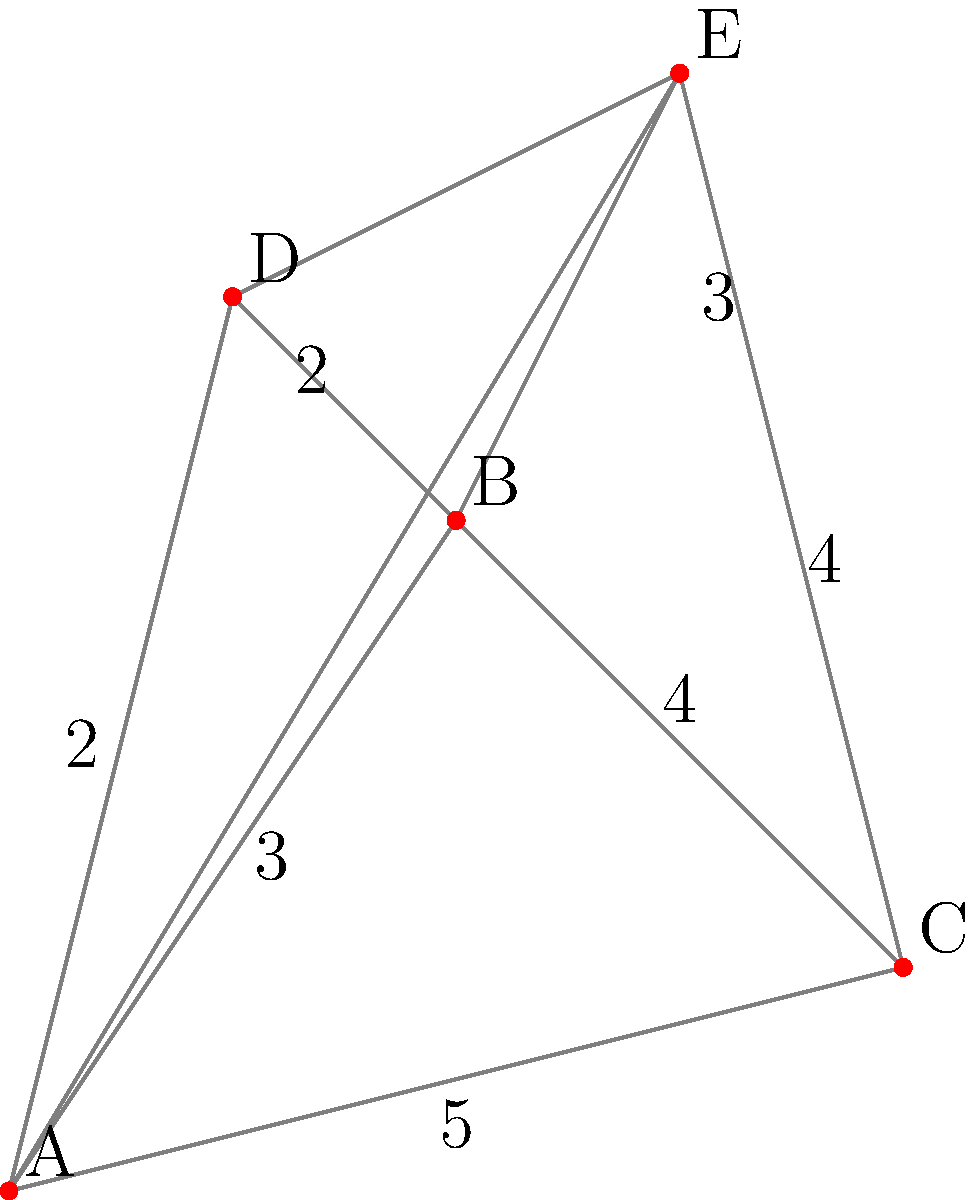As a transportation manager, you need to plan the most efficient route for coffee deliveries. Given the city map above, where each node represents a delivery location and the numbers on the edges represent distances in kilometers, what is the shortest possible route that visits all locations exactly once and returns to the starting point? To solve this problem, we need to find the shortest Hamiltonian cycle, which is known as the Traveling Salesman Problem (TSP). For a small number of nodes like this, we can use a brute-force approach:

1. List all possible permutations of the cities (excluding the starting point).
2. For each permutation, calculate the total distance of the route.
3. Choose the permutation with the shortest total distance.

Let's calculate for all permutations starting from A:

1. A-B-C-D-E-A: 3 + 4 + 2 + 3 + 4 = 16 km
2. A-B-C-E-D-A: 3 + 4 + 3 + 2 + 2 = 14 km
3. A-B-D-C-E-A: 3 + 2 + 4 + 3 + 4 = 16 km
4. A-B-D-E-C-A: 3 + 2 + 3 + 4 + 5 = 17 km
5. A-B-E-C-D-A: 3 + 3 + 4 + 2 + 2 = 14 km
6. A-B-E-D-C-A: 3 + 3 + 2 + 4 + 5 = 17 km
7. A-C-B-D-E-A: 5 + 3 + 2 + 3 + 4 = 17 km
8. A-C-B-E-D-A: 5 + 3 + 3 + 2 + 2 = 15 km
9. A-C-D-B-E-A: 5 + 2 + 2 + 3 + 4 = 16 km
10. A-C-D-E-B-A: 5 + 2 + 3 + 3 + 3 = 16 km
11. A-C-E-B-D-A: 5 + 3 + 3 + 2 + 2 = 15 km
12. A-C-E-D-B-A: 5 + 3 + 2 + 2 + 3 = 15 km

The shortest routes are A-B-C-E-D-A and A-B-E-C-D-A, both with a total distance of 14 km.
Answer: 14 km (A-B-C-E-D-A or A-B-E-C-D-A) 